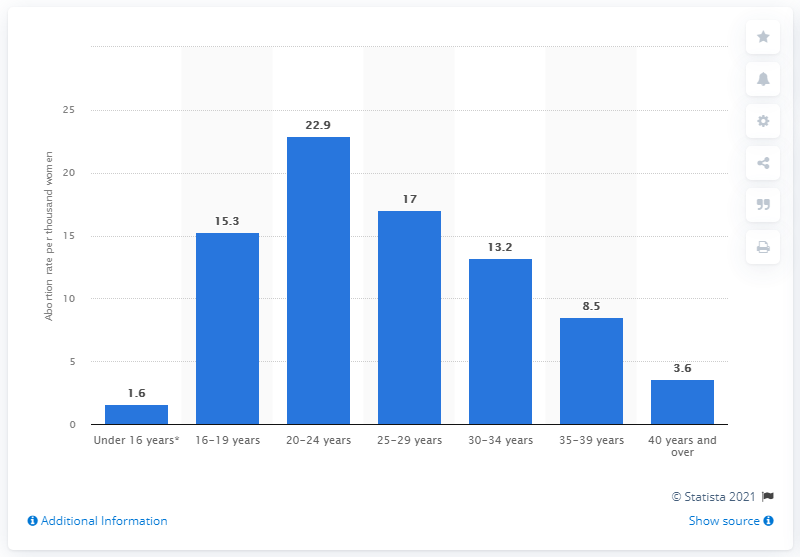Identify some key points in this picture. In 2019, an estimated 22.9 abortions per 1,000 women were performed in Scotland. 